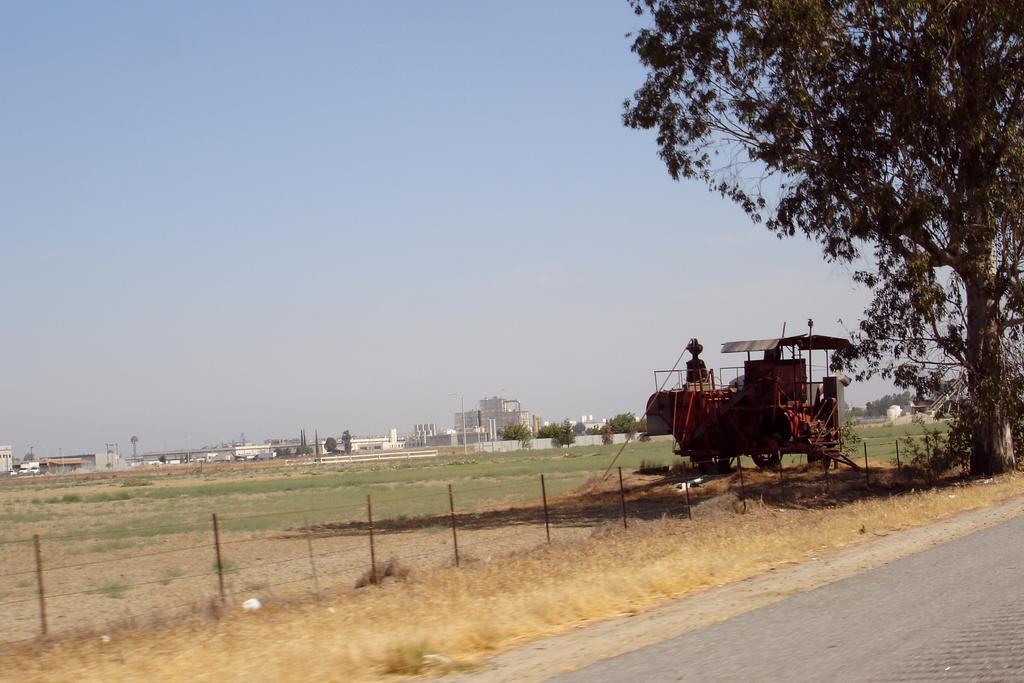How would you summarize this image in a sentence or two? This is an outside view. On the right side, I can see a road. Beside the road there is a tree, under this tree there is a vehicle. In the background there are some buildings and trees. On the top of the image I can see the sky. 